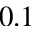Convert formula to latex. <formula><loc_0><loc_0><loc_500><loc_500>0 . 1</formula> 